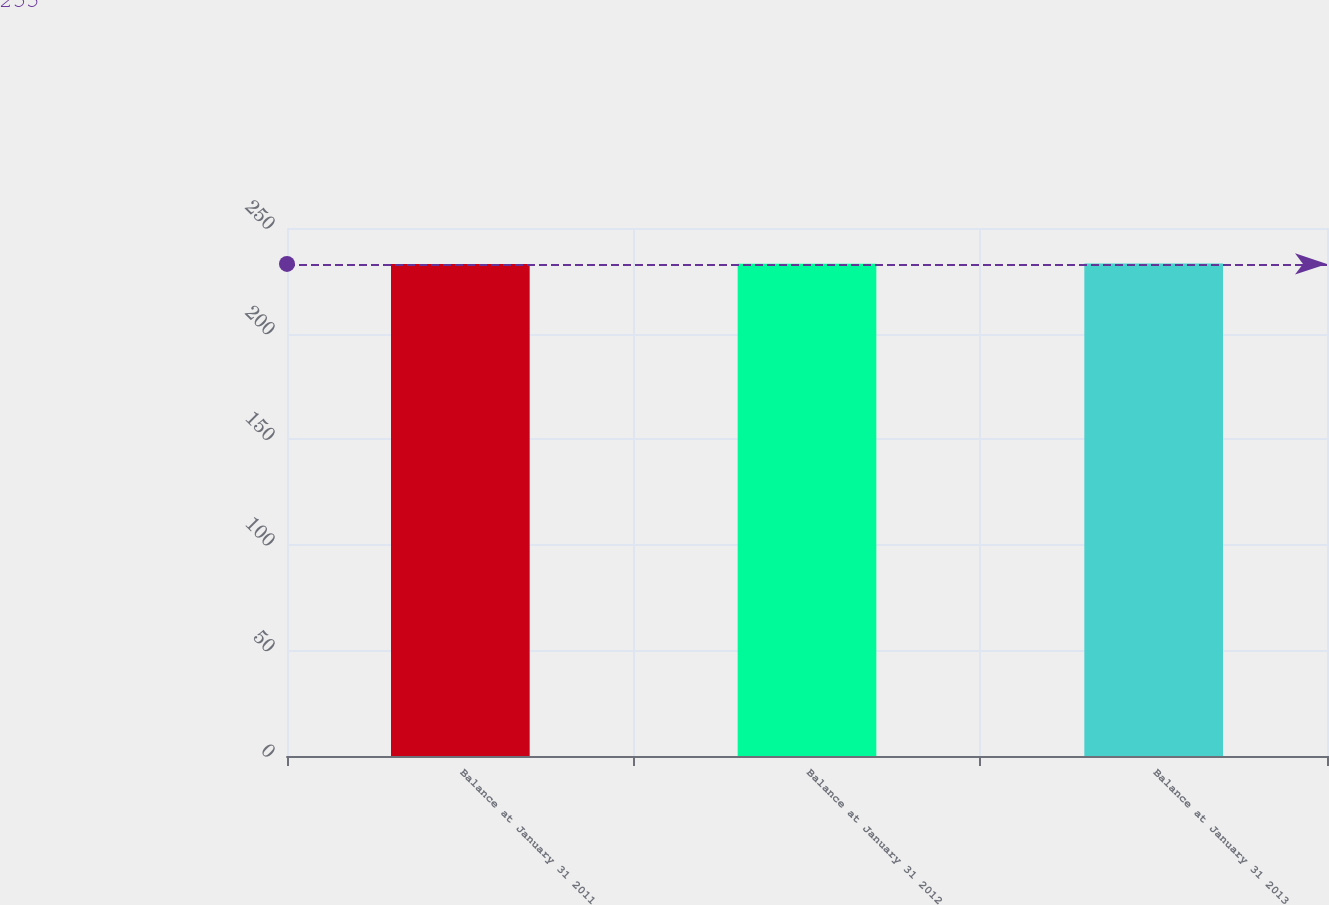Convert chart to OTSL. <chart><loc_0><loc_0><loc_500><loc_500><bar_chart><fcel>Balance at January 31 2011<fcel>Balance at January 31 2012<fcel>Balance at January 31 2013<nl><fcel>233<fcel>233.1<fcel>233.2<nl></chart> 